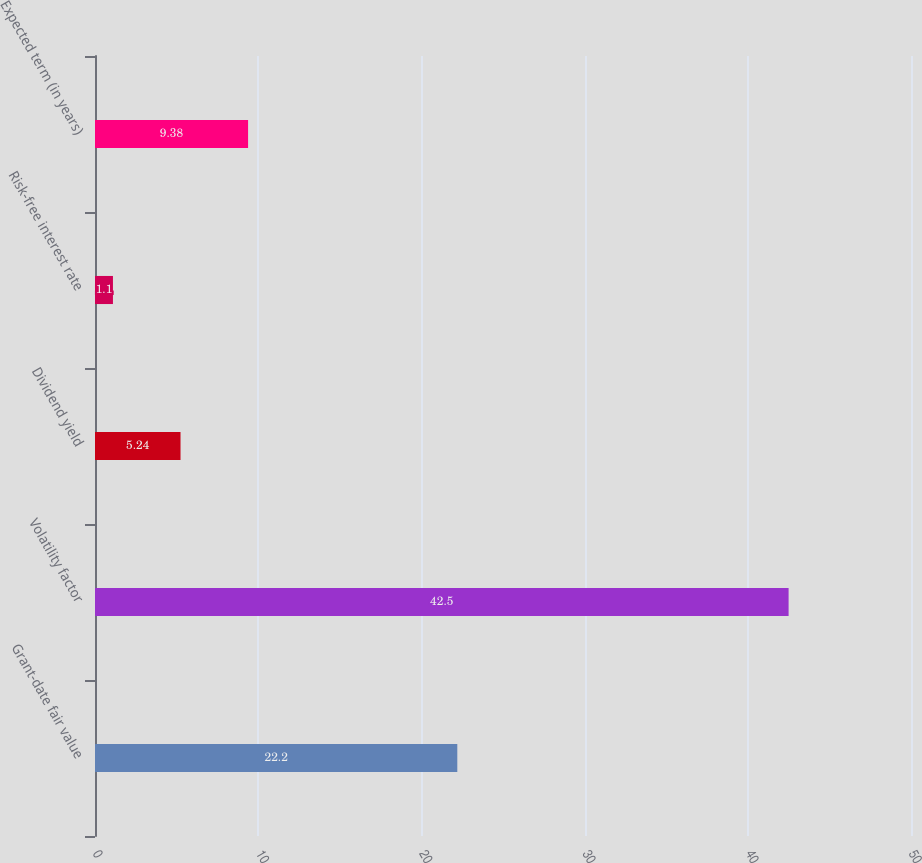<chart> <loc_0><loc_0><loc_500><loc_500><bar_chart><fcel>Grant-date fair value<fcel>Volatility factor<fcel>Dividend yield<fcel>Risk-free interest rate<fcel>Expected term (in years)<nl><fcel>22.2<fcel>42.5<fcel>5.24<fcel>1.1<fcel>9.38<nl></chart> 